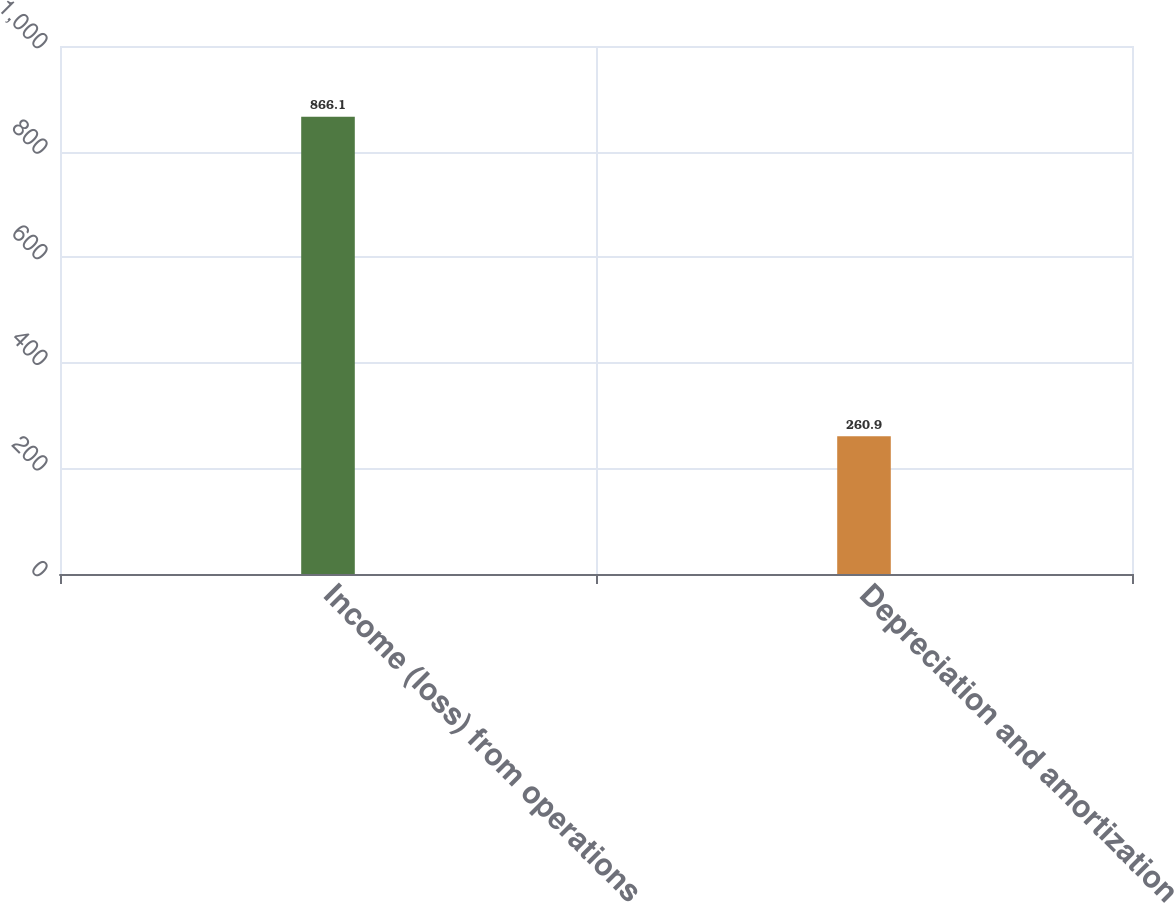Convert chart. <chart><loc_0><loc_0><loc_500><loc_500><bar_chart><fcel>Income (loss) from operations<fcel>Depreciation and amortization<nl><fcel>866.1<fcel>260.9<nl></chart> 